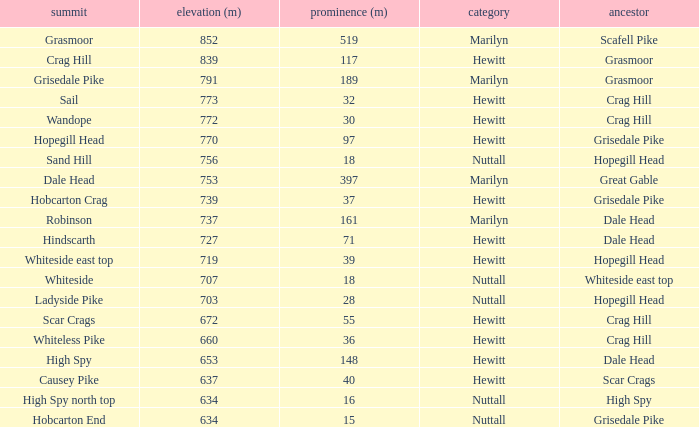Which Parent has height smaller than 756 and a Prom of 39? Hopegill Head. 